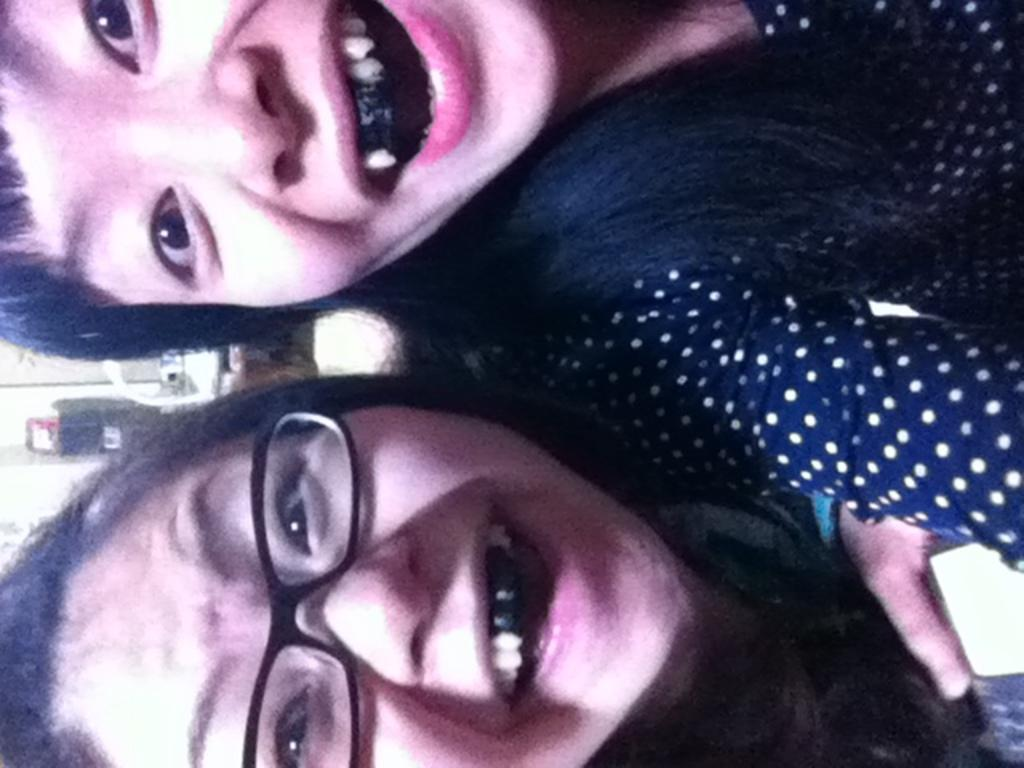How many people are in the image? There are two girls in the image. What is a noticeable feature of the girls' teeth? The girls have black teeth. How is the image oriented? The image is vertical. What type of volleyball game is being played in the image? There is no volleyball game present in the image. What statement can be made about the girls' dental hygiene based on their black teeth? The girls' black teeth suggest that they may have poor dental hygiene or have consumed something that stained their teeth. 